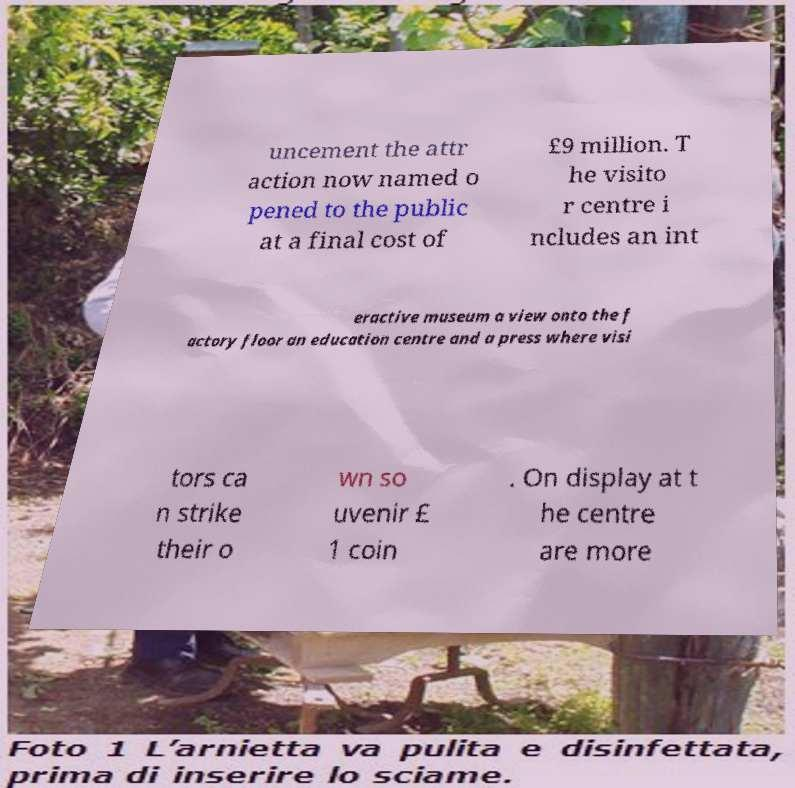Please read and relay the text visible in this image. What does it say? uncement the attr action now named o pened to the public at a final cost of £9 million. T he visito r centre i ncludes an int eractive museum a view onto the f actory floor an education centre and a press where visi tors ca n strike their o wn so uvenir £ 1 coin . On display at t he centre are more 